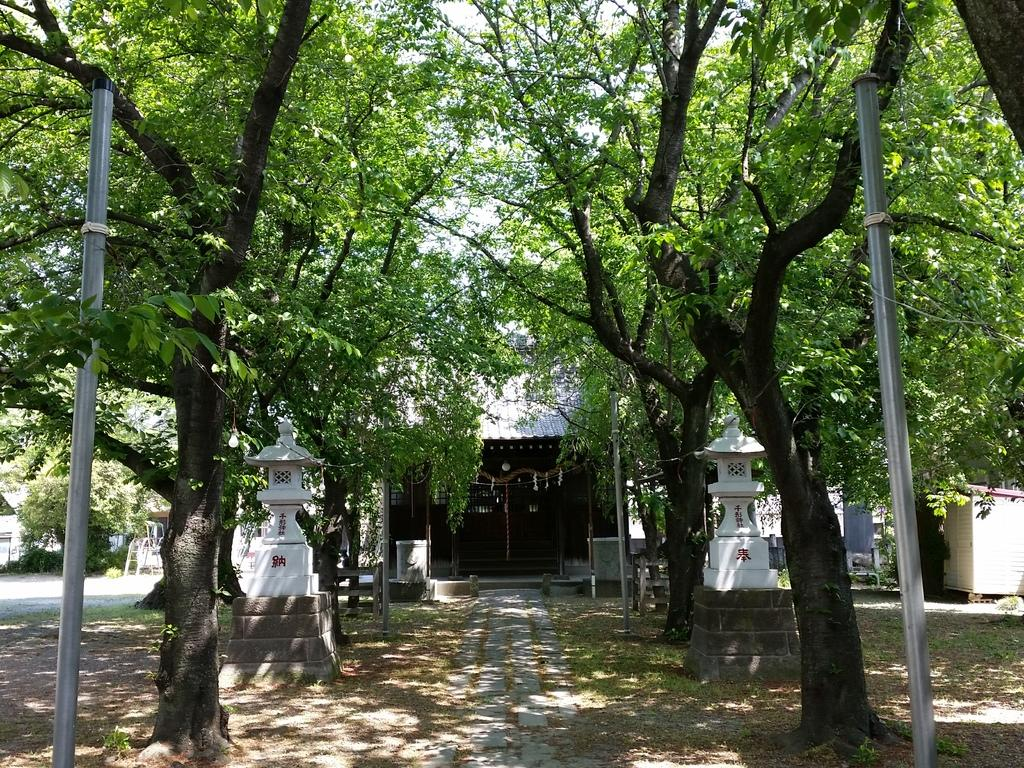What type of structures can be seen in the image? There are houses in the image. What type of vegetation is present in the image? There are trees in the image. What else can be seen in the image besides houses and trees? There are poles in the image. What is the ground covered with in the image? Grass is visible on the ground in the image. Where is the crate of yaks located in the image? There is no crate of yaks present in the image. What type of expansion is visible in the image? There is no expansion visible in the image; it features houses, trees, poles, and grass. 